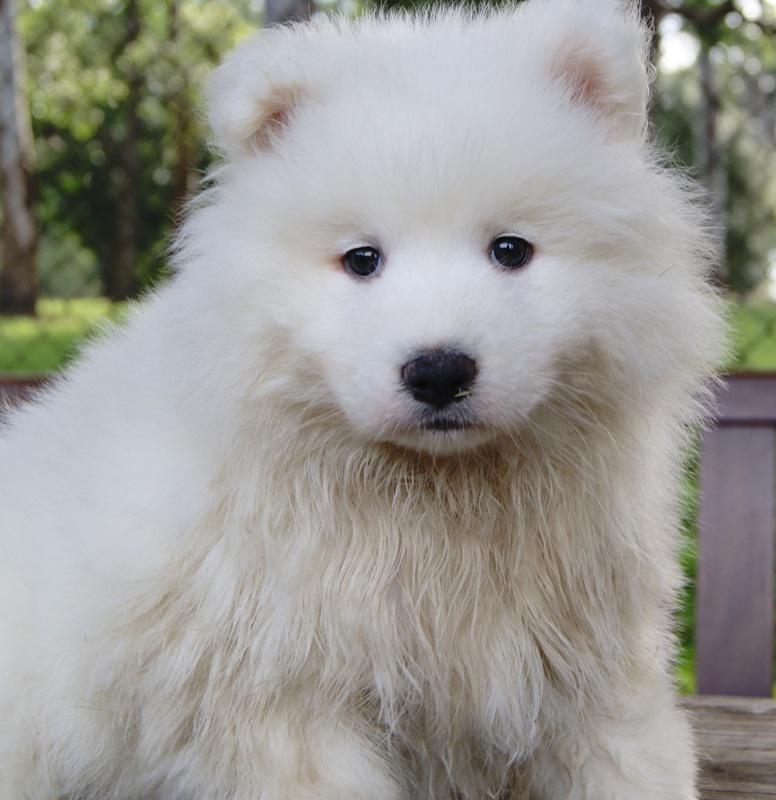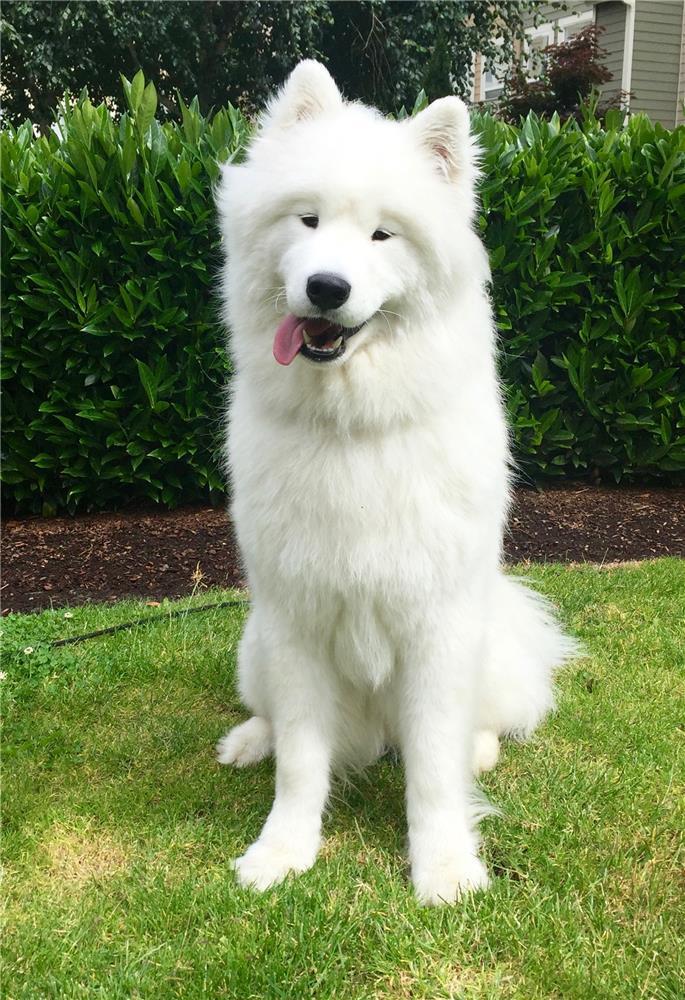The first image is the image on the left, the second image is the image on the right. For the images displayed, is the sentence "there ia a puppy sitting on something that isn't grass" factually correct? Answer yes or no. No. The first image is the image on the left, the second image is the image on the right. For the images shown, is this caption "There are exactly three dogs." true? Answer yes or no. No. 